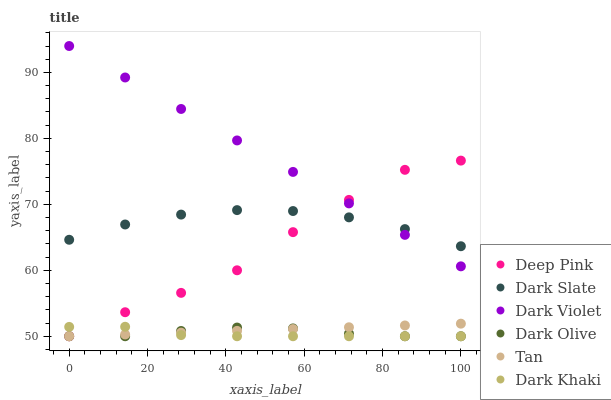Does Dark Khaki have the minimum area under the curve?
Answer yes or no. Yes. Does Dark Violet have the maximum area under the curve?
Answer yes or no. Yes. Does Dark Olive have the minimum area under the curve?
Answer yes or no. No. Does Dark Olive have the maximum area under the curve?
Answer yes or no. No. Is Tan the smoothest?
Answer yes or no. Yes. Is Deep Pink the roughest?
Answer yes or no. Yes. Is Dark Olive the smoothest?
Answer yes or no. No. Is Dark Olive the roughest?
Answer yes or no. No. Does Deep Pink have the lowest value?
Answer yes or no. Yes. Does Dark Violet have the lowest value?
Answer yes or no. No. Does Dark Violet have the highest value?
Answer yes or no. Yes. Does Dark Olive have the highest value?
Answer yes or no. No. Is Dark Khaki less than Dark Violet?
Answer yes or no. Yes. Is Dark Slate greater than Dark Olive?
Answer yes or no. Yes. Does Dark Violet intersect Deep Pink?
Answer yes or no. Yes. Is Dark Violet less than Deep Pink?
Answer yes or no. No. Is Dark Violet greater than Deep Pink?
Answer yes or no. No. Does Dark Khaki intersect Dark Violet?
Answer yes or no. No. 